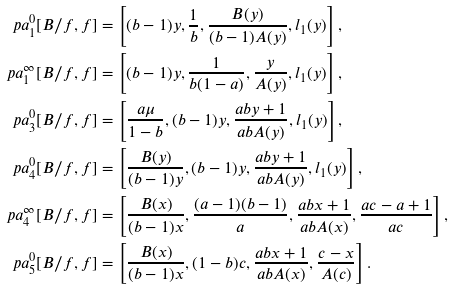Convert formula to latex. <formula><loc_0><loc_0><loc_500><loc_500>\ p a _ { 1 } ^ { 0 } [ B / f , f ] & = \left [ ( b - 1 ) y , \frac { 1 } { b } , \frac { B ( y ) } { ( b - 1 ) A ( y ) } , l _ { 1 } ( y ) \right ] , \\ \ p a _ { 1 } ^ { \infty } [ B / f , f ] & = \left [ ( b - 1 ) y , \frac { 1 } { b ( 1 - a ) } , \frac { y } { A ( y ) } , l _ { 1 } ( y ) \right ] , \\ \ p a _ { 3 } ^ { 0 } [ B / f , f ] & = \left [ \frac { a \mu } { 1 - b } , ( b - 1 ) y , \frac { a b y + 1 } { a b A ( y ) } , l _ { 1 } ( y ) \right ] , \\ \ p a _ { 4 } ^ { 0 } [ B / f , f ] & = \left [ \frac { B ( y ) } { ( b - 1 ) y } , ( b - 1 ) y , \frac { a b y + 1 } { a b A ( y ) } , l _ { 1 } ( y ) \right ] , \\ \ p a _ { 4 } ^ { \infty } [ B / f , f ] & = \left [ \frac { B ( x ) } { ( b - 1 ) x } , \frac { ( a - 1 ) ( b - 1 ) } { a } , \frac { a b x + 1 } { a b A ( x ) } , \frac { a c - a + 1 } { a c } \right ] , \\ \ p a _ { 5 } ^ { 0 } [ B / f , f ] & = \left [ \frac { B ( x ) } { ( b - 1 ) x } , ( 1 - b ) c , \frac { a b x + 1 } { a b A ( x ) } , \frac { c - x } { A ( c ) } \right ] .</formula> 